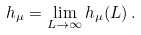Convert formula to latex. <formula><loc_0><loc_0><loc_500><loc_500>h _ { \mu } = \lim _ { L \rightarrow \infty } h _ { \mu } ( L ) \, .</formula> 